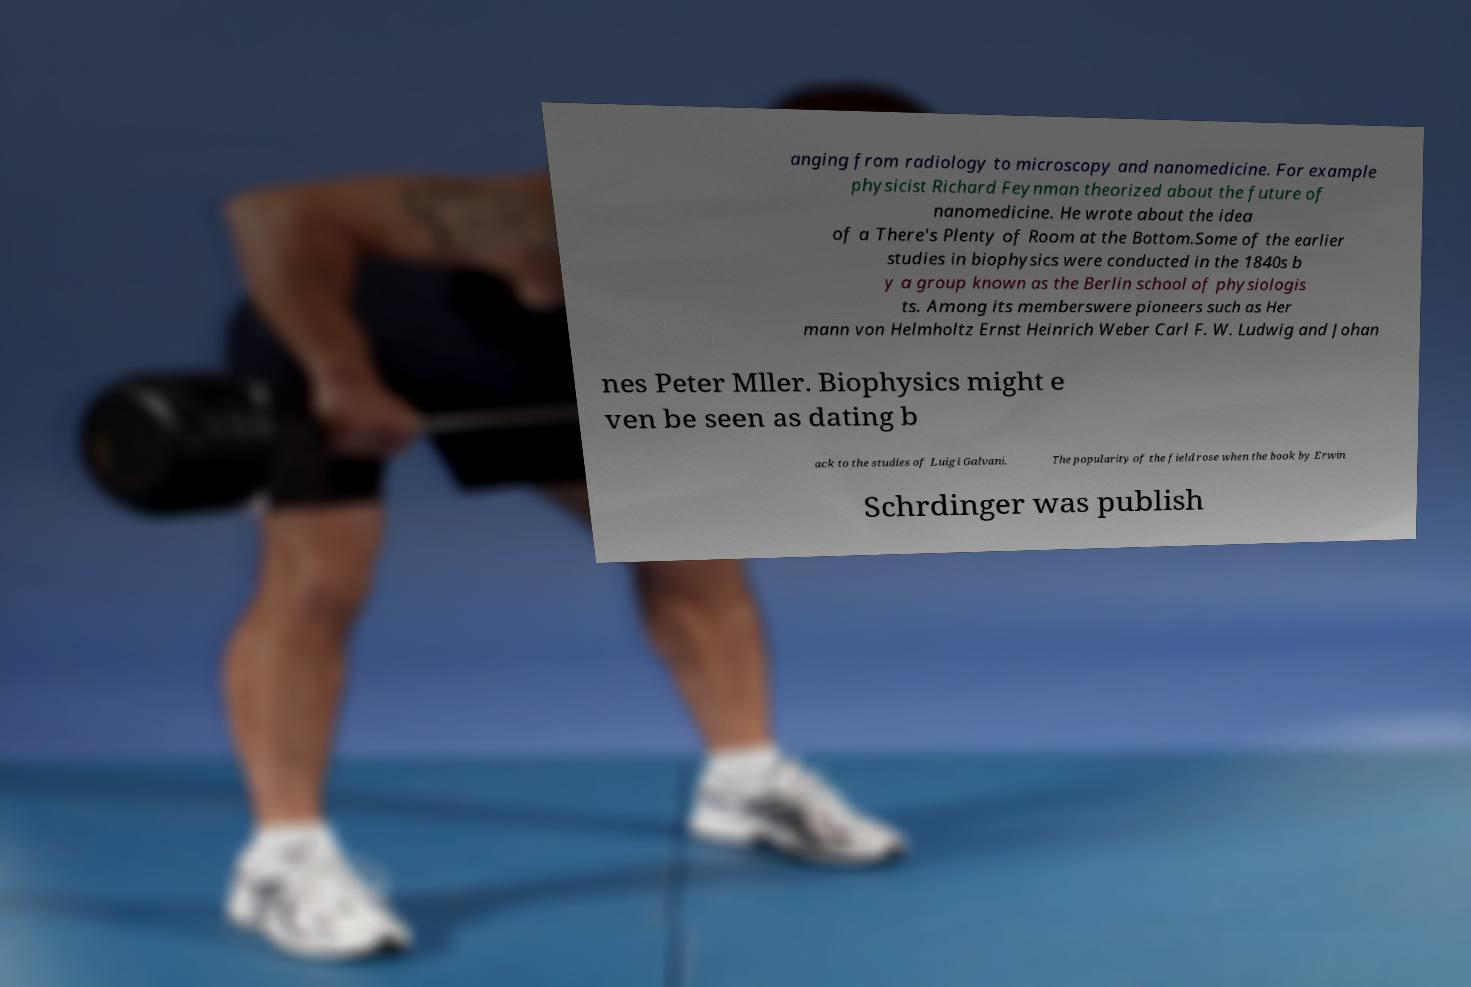What messages or text are displayed in this image? I need them in a readable, typed format. anging from radiology to microscopy and nanomedicine. For example physicist Richard Feynman theorized about the future of nanomedicine. He wrote about the idea of a There's Plenty of Room at the Bottom.Some of the earlier studies in biophysics were conducted in the 1840s b y a group known as the Berlin school of physiologis ts. Among its memberswere pioneers such as Her mann von Helmholtz Ernst Heinrich Weber Carl F. W. Ludwig and Johan nes Peter Mller. Biophysics might e ven be seen as dating b ack to the studies of Luigi Galvani. The popularity of the field rose when the book by Erwin Schrdinger was publish 